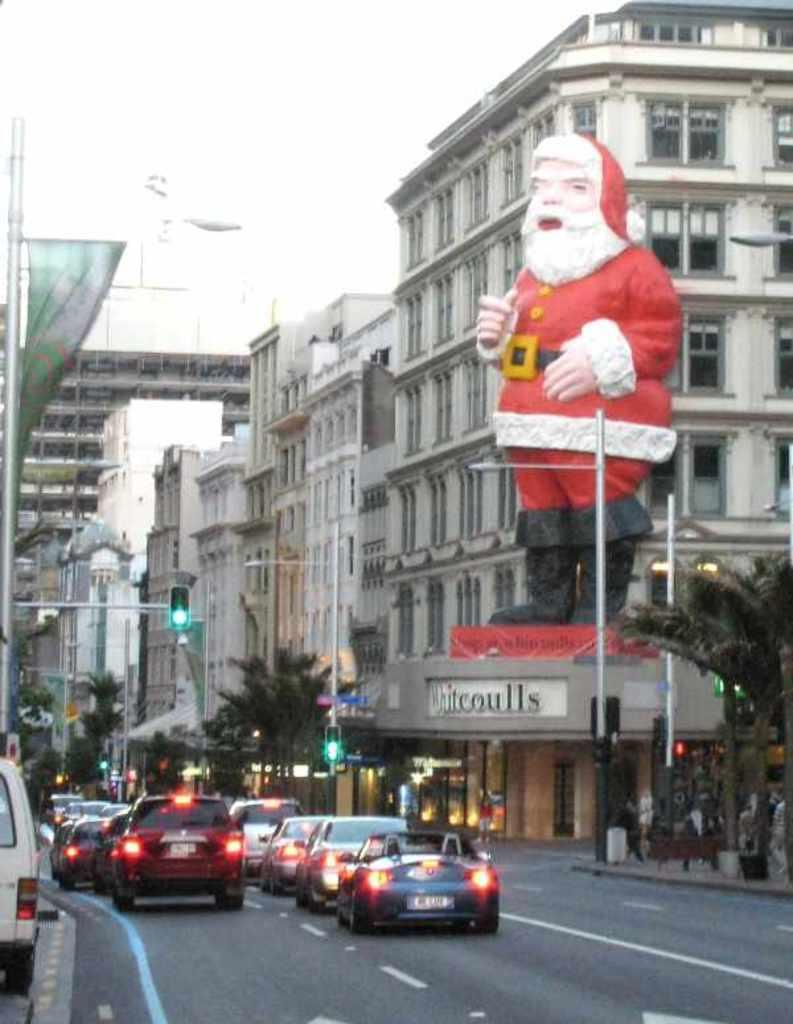What type of structures can be seen in the image? There are buildings in the image. What other natural elements are present in the image? There are trees in the image. What type of establishments can be found in the image? There are stores in the image. What mode of transportation can be seen on the road in the image? There are cars on the road in the image. What is visible at the top of the image? The sky is visible at the top of the image. Can you describe any festive or seasonal elements in the image? Yes, there is a depiction of Santa Claus in the image. What type of error can be seen in the image? There is no error present in the image. Can you describe the zipper on the Santa Claus's outfit in the image? There is no zipper present on the Santa Claus's outfit in the image. 